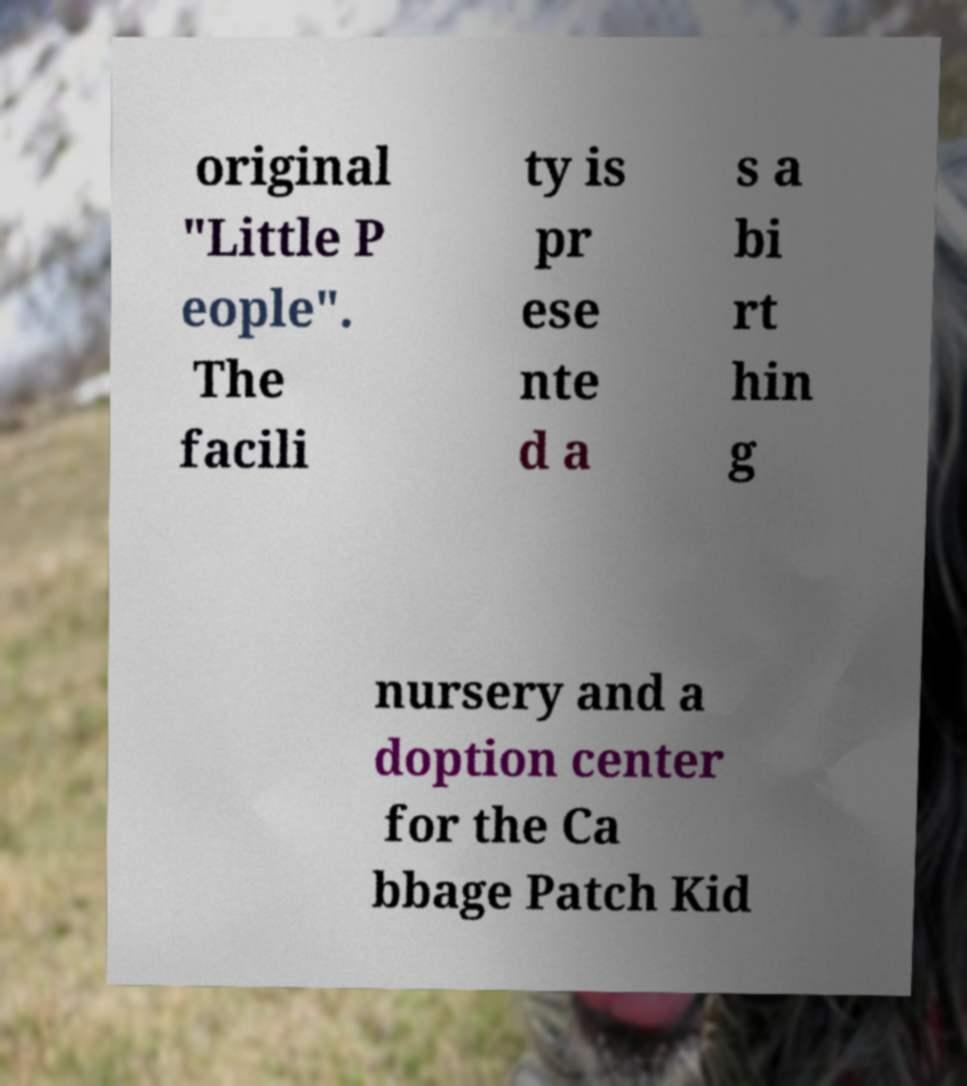For documentation purposes, I need the text within this image transcribed. Could you provide that? original "Little P eople". The facili ty is pr ese nte d a s a bi rt hin g nursery and a doption center for the Ca bbage Patch Kid 